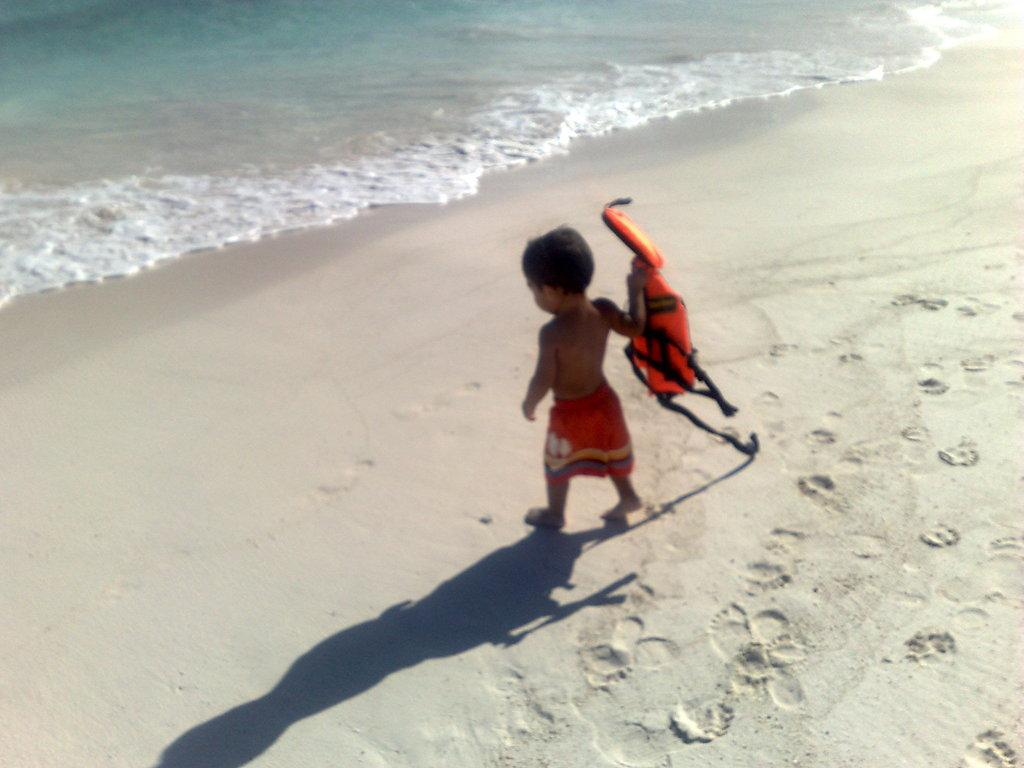What is the main subject of the image? The main subject of the image is a kid. What is the kid doing in the image? The kid is walking on the sand. What is the kid holding in their hand? The kid is holding an object in their hand. What can be seen on the sand in the image? There is a shadow on the sand. What is visible in the background of the image? There is water visible in the background of the image. What is the chance of the kid measuring the distance they walked on the sand? There is no indication in the image that the kid is measuring the distance they walked, nor is there any mention of a measuring tool. 